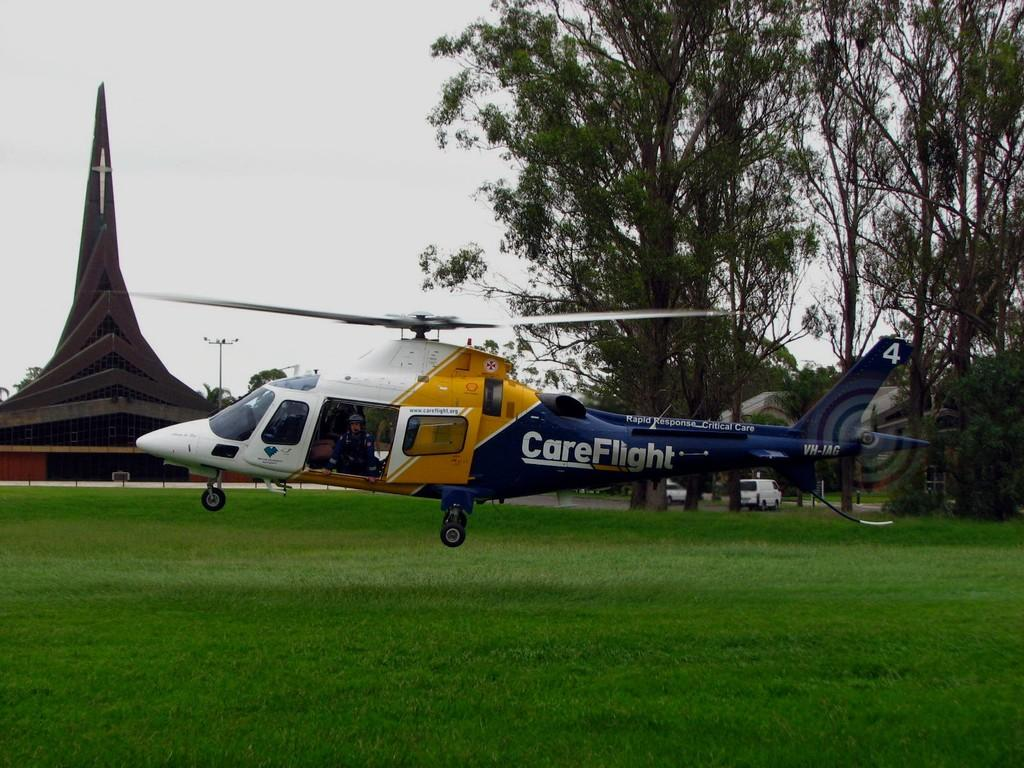What is flying in the air in the image? There is a helicopter flying in the air in the image. What can be seen in the background of the image? There is an architectural building, vehicles, trees, and the sky visible in the background. Can you describe the building in the background? The provided facts do not give specific details about the building, but it is an architectural structure visible in the background. What type of plants can be seen on the desk in the image? There is no desk present in the image, and therefore no plants on a desk can be observed. 